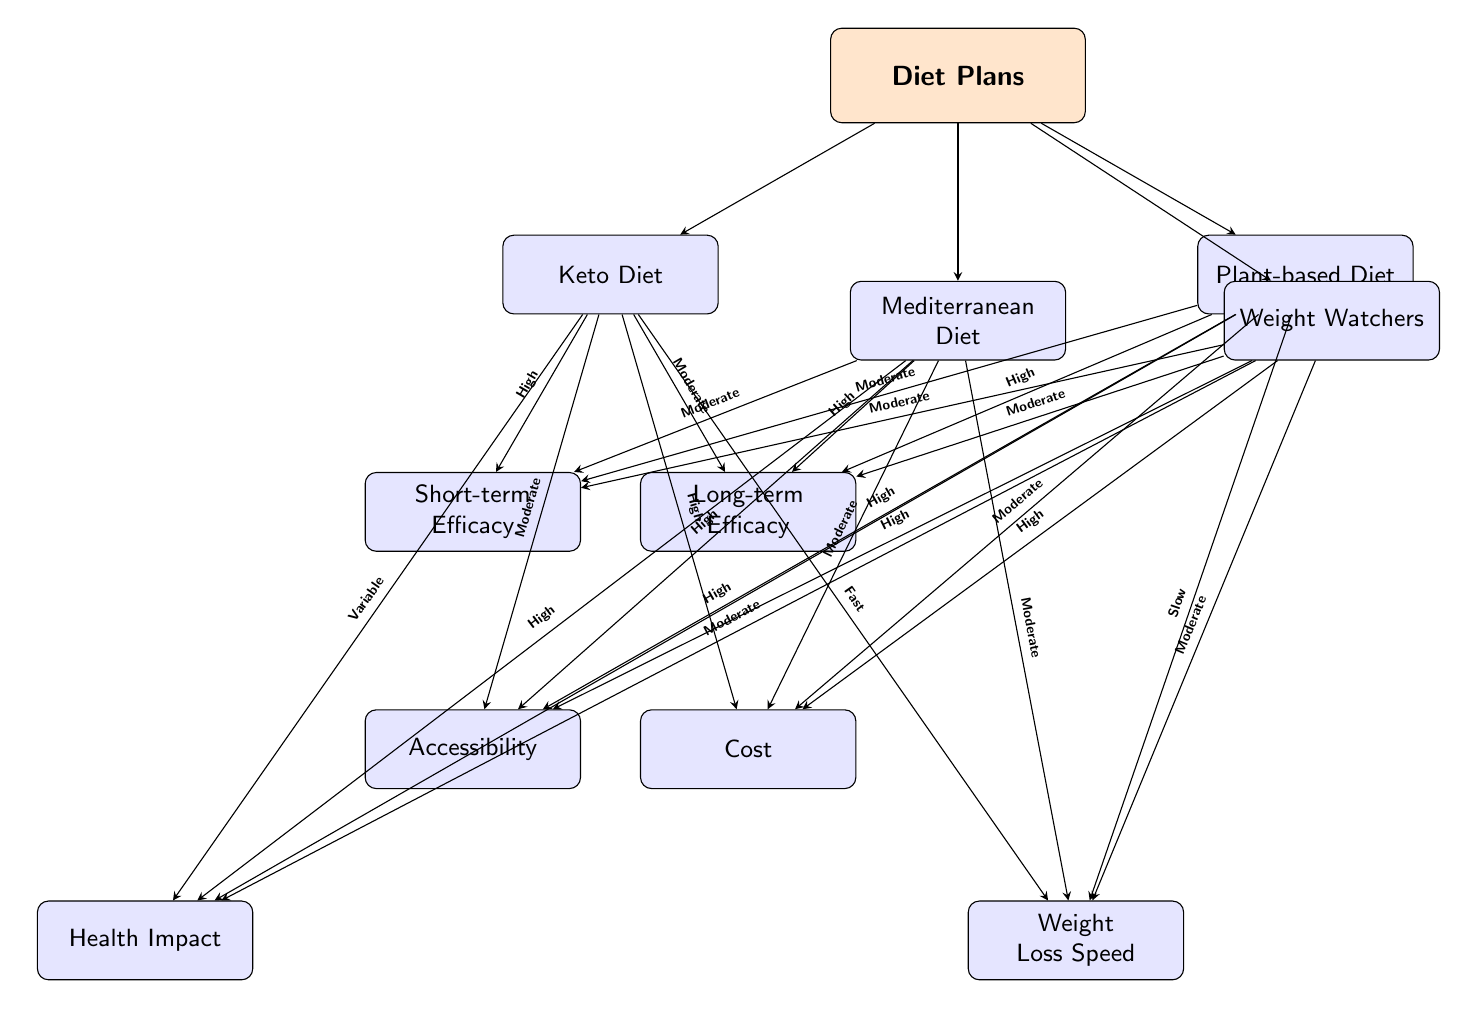What are the four diet plans depicted in the diagram? The diagram lists Keto Diet, Mediterranean Diet, Plant-based Diet, and Weight Watchers as the four main diet plans.
Answer: Keto Diet, Mediterranean Diet, Plant-based Diet, Weight Watchers Which diet plan is associated with high long-term efficacy? Looking at the 'Long-term Efficacy' node, the Mediterranean Diet and Plant-based Diet both have high efficacy ratings indicated in the diagram.
Answer: Mediterranean Diet, Plant-based Diet What is the weight loss speed of the Plant-based Diet? The diagram points out the 'Weight Loss Speed' for the Plant-based Diet specifically and states it as 'Slow.'
Answer: Slow Which diet plan has a moderate cost rating? Analyzing the cost attributes for each diet plan, the Mediterranean Diet and Plant-based Diet have a 'Moderate' cost rating indicated in the diagram.
Answer: Mediterranean Diet, Plant-based Diet How does the accessibility of the Weight Watchers compare to the other diet plans? Checking the 'Accessibility' node reveals that Weight Watchers is rated 'High', the same as Mediterranean Diet and Plant-based Diet, making it just as accessible.
Answer: High Which diet plan has a variable health impact? The diagram indicates that the Keto Diet has a 'Variable' health impact.
Answer: Variable What is the short-term efficacy of the Mediterranean Diet? According to the diagram, the short-term efficacy for the Mediterranean Diet is indicated as 'Moderate.'
Answer: Moderate Which diet plan offers the fastest weight loss speed? The weight loss speed for Keto Diet is noted as 'Fast' in the diagram, making it the fastest among all options.
Answer: Fast Which diet plan has high accessibility and high long-term efficacy at the same time? The Mediterranean Diet and Plant-based Diet both show high accessibility and high long-term efficacy ratings, confirming their effectiveness in both areas.
Answer: Mediterranean Diet, Plant-based Diet 